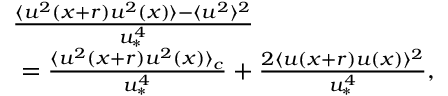Convert formula to latex. <formula><loc_0><loc_0><loc_500><loc_500>\begin{array} { r l } & { \frac { \langle u ^ { 2 } ( x + r ) u ^ { 2 } ( x ) \rangle - \langle u ^ { 2 } \rangle ^ { 2 } } { u _ { \ast } ^ { 4 } } } \\ & { \ = \frac { \langle u ^ { 2 } ( x + r ) u ^ { 2 } ( x ) \rangle _ { c } } { u _ { \ast } ^ { 4 } } + \frac { 2 \langle u ( x + r ) u ( x ) \rangle ^ { 2 } } { u _ { \ast } ^ { 4 } } , } \end{array}</formula> 